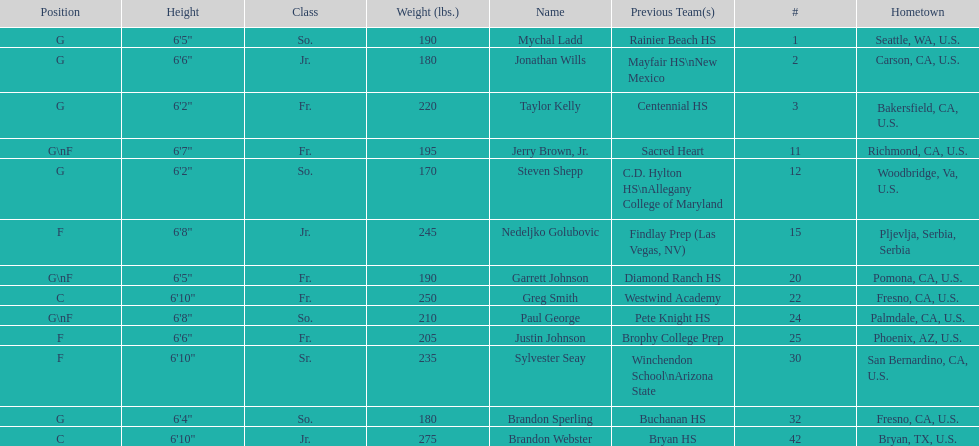Who is the next heaviest player after nedelijko golubovic? Sylvester Seay. 